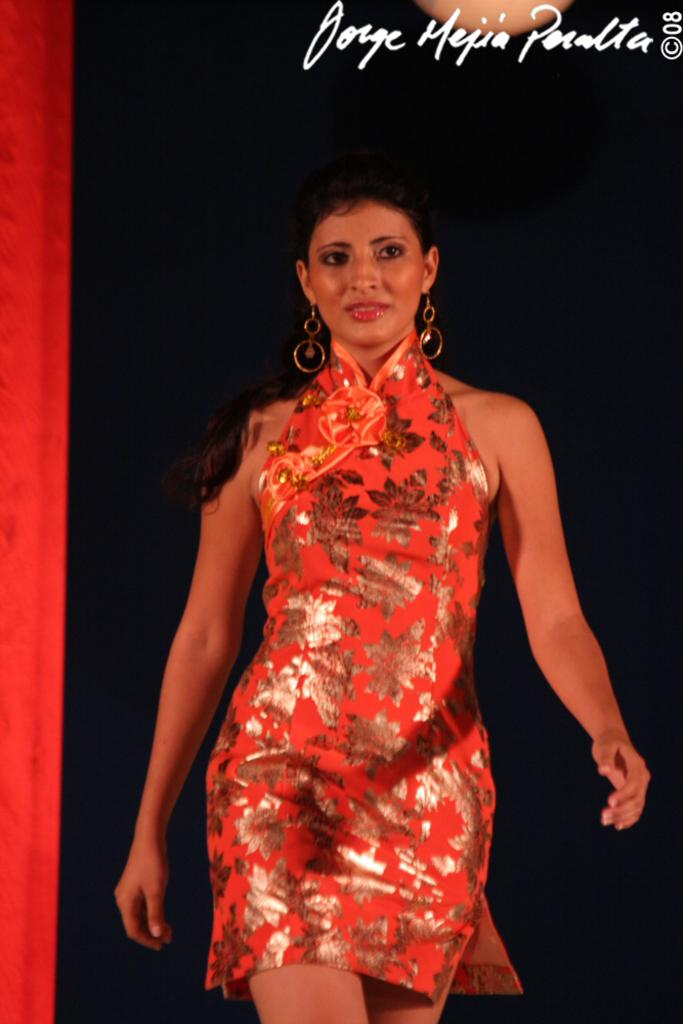Who is present in the image? There is a woman in the image. What is the woman wearing in the image? The woman is wearing earrings in the image. What is the woman doing in the image? The woman is walking in the image. Is there any additional information about the image itself? Yes, there is a watermark in the right top corner of the image. What type of mint is growing near the woman in the image? There is no mint present in the image. What theory is the woman discussing with her companion in the image? There is no companion or discussion about a theory in the image; the woman is simply walking. 